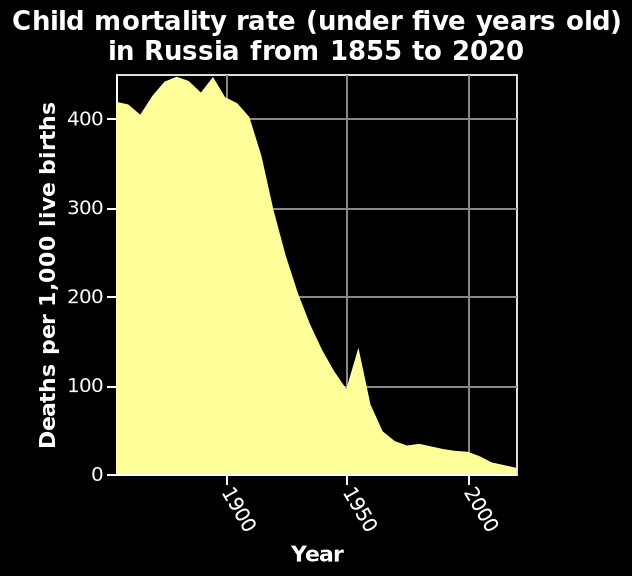<image>
What was the trend of child mortality rate between 1855 and 2020 based on the graphic? The graphic suggests that the child mortality rate decreased continuously from 1855 to 2020. 